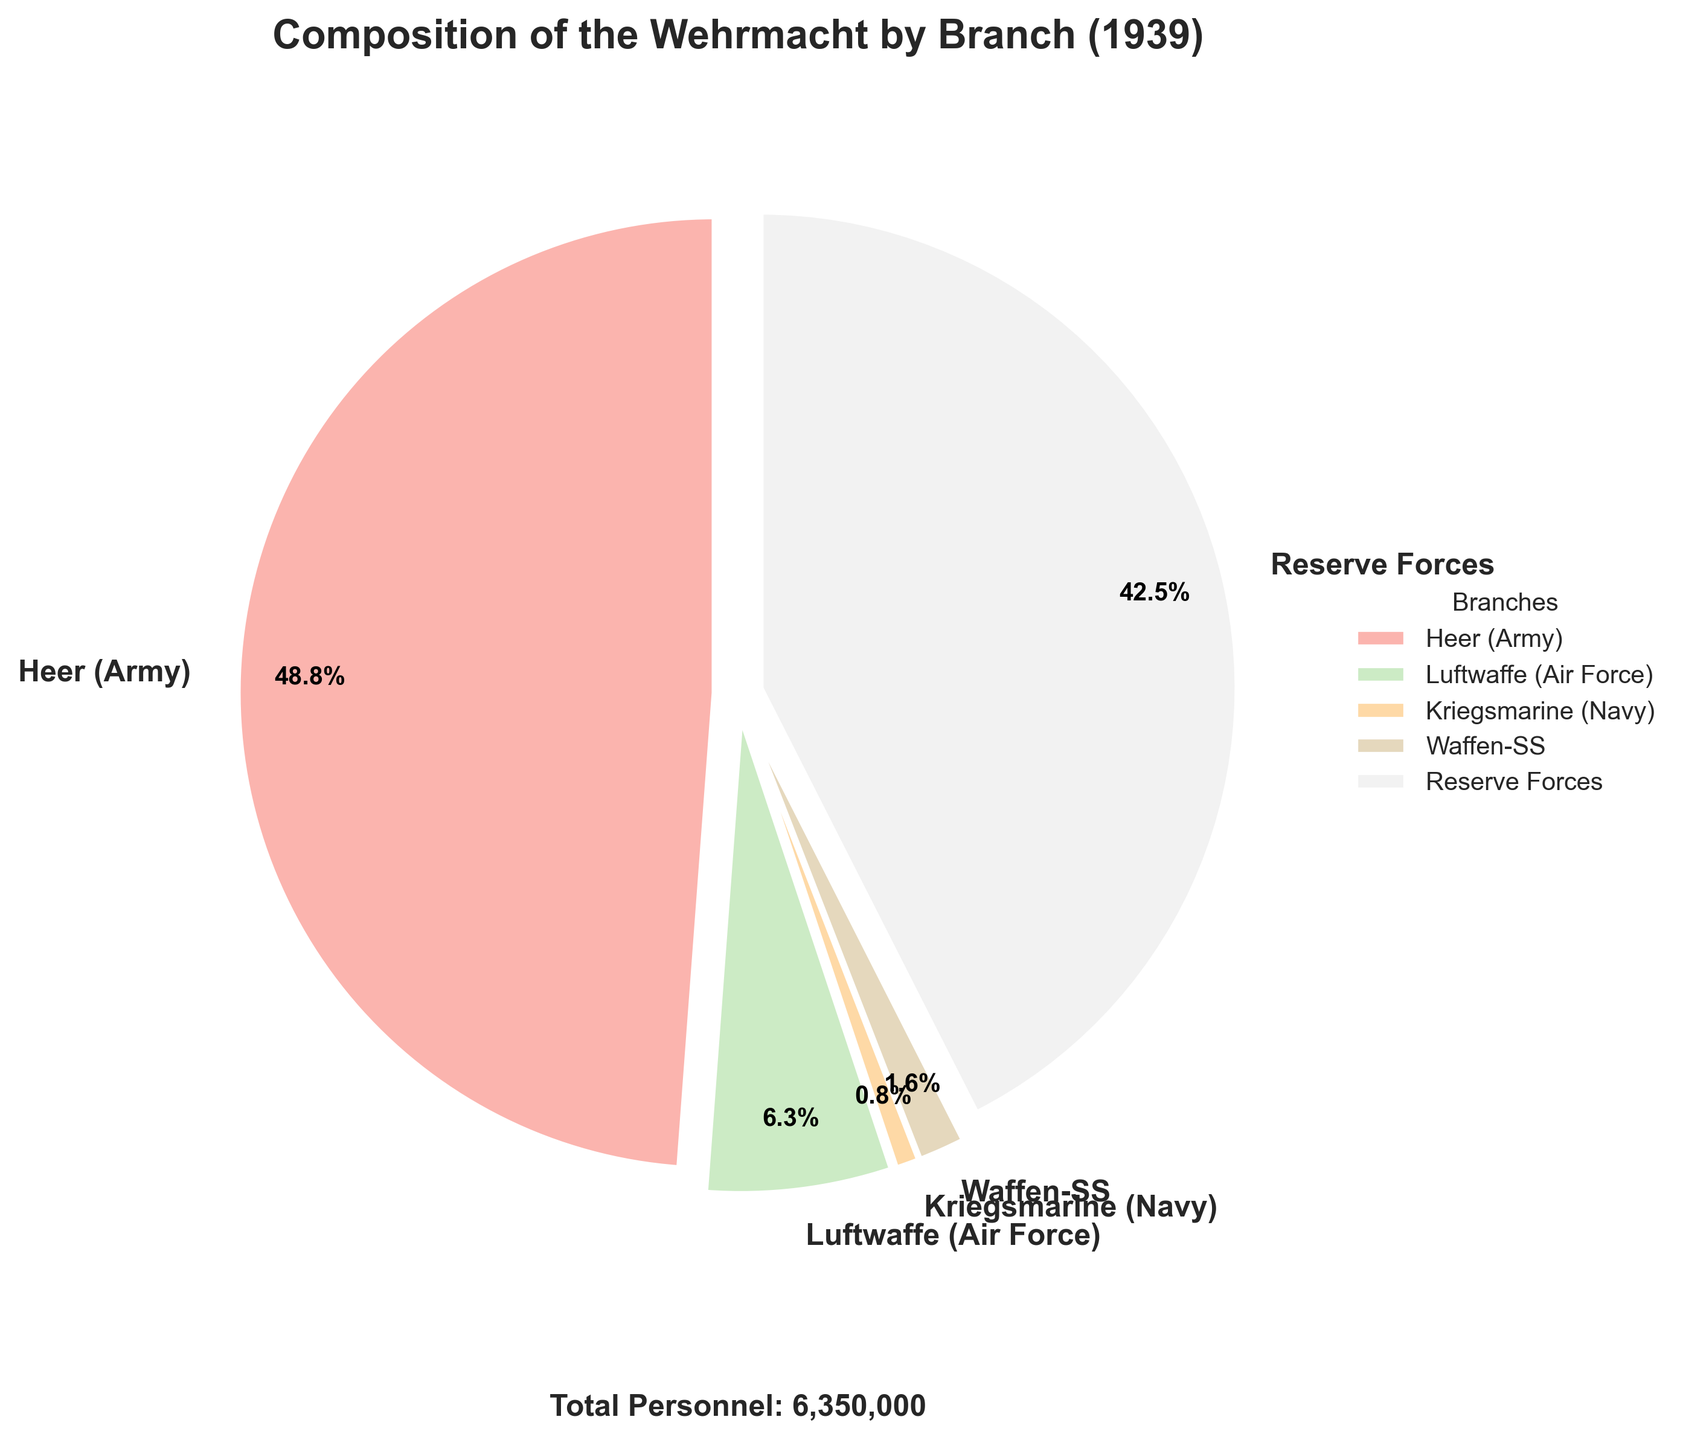How many branches are included in the chart? The chart includes 5 branches: Heer (Army), Luftwaffe (Air Force), Kriegsmarine (Navy), Waffen-SS, and Reserve Forces.
Answer: 5 Which branch has the highest percentage of personnel? The Heer (Army) is represented by the largest wedge in the pie chart and has the highest percentage of personnel, significantly larger than the other branches.
Answer: Heer (Army) What is the percentage of the Luftwaffe (Air Force) personnel? The pie chart shows the percentage value directly next to the Luftwaffe (Air Force) wedge.
Answer: 6.7% How much larger is the Heer (Army) compared to the Luftwaffe (Air Force) in terms of personnel? By referring to the legend, Heer (Army) has 3,100,000 personnel, and the Luftwaffe (Air Force) has 400,000. To find the difference, subtract the number of Luftwaffe personnel from Heer personnel: 3,100,000 - 400,000.
Answer: 2,700,000 What proportion of the total Wehrmacht personnel is represented by the Reserve Forces? The pie chart indicates the percentage of Reserve Forces personnel. Given that the total personnel is shown as 6,250,000, dividing the number of Reserve Forces by the total personnel verifies the percentage value.
Answer: 43.2% Between the Waffen-SS and Kriegsmarine (Navy), which branch has more personnel and by what amount? The legend indicates that the Waffen-SS has 100,000 personnel, and the Kriegsmarine (Navy) has 50,000 personnel. To find the difference, subtract the number of Kriegsmarine personnel from the Waffen-SS personnel: 100,000 - 50,000.
Answer: Waffen-SS, 50,000 What is the combined percentage of Heer (Army) and Reserve Forces personnel? The chart shows the percentage for Heer (Army) as 49.6% and for Reserve Forces as 43.2%. Adding these two percentages gives the combined percentage: 49.6% + 43.2%.
Answer: 92.8% Which is the smallest represented branch in the pie chart? By comparing the size of the wedges, the Kriegsmarine (Navy) is the smallest wedge.
Answer: Kriegsmarine (Navy) What is the total number of personnel depicted in the pie chart? The total number of personnel is displayed below the pie chart as 6,250,000. This number is the sum of all personnel in the branches represented in the chart.
Answer: 6,250,000 